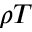<formula> <loc_0><loc_0><loc_500><loc_500>\rho T</formula> 